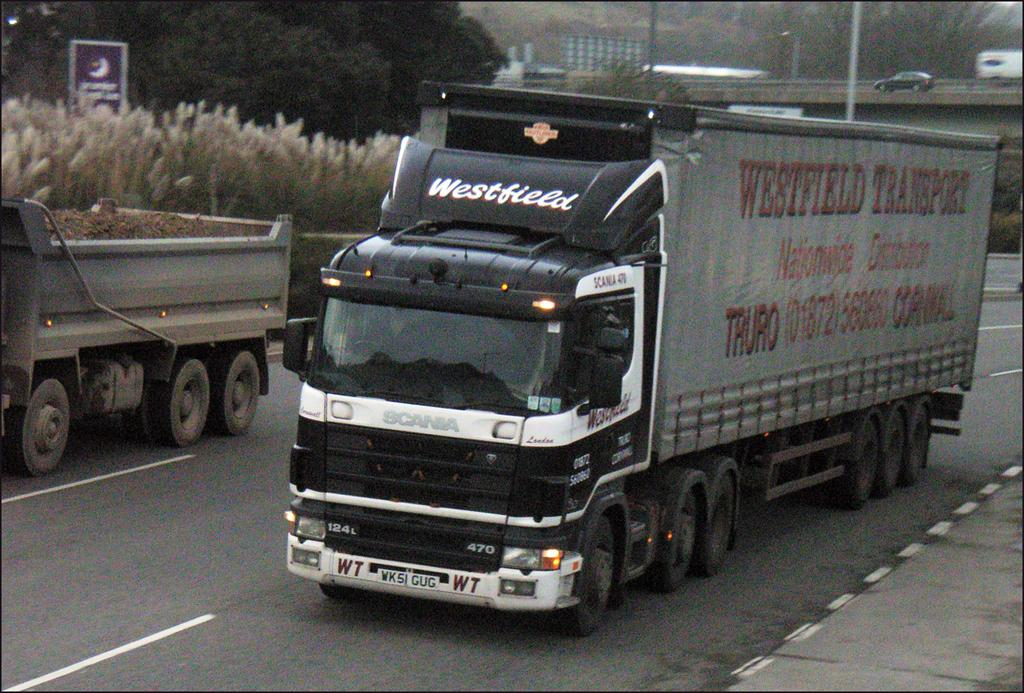What can be seen in the foreground of the picture? There are two trucks on a road and a footpath in the foreground of the picture. What is located in the center of the picture? In the center of the picture, there are plants, trees, a bridge, poles, and vehicles. Can you describe the types of plants and trees in the center of the picture? The specific types of plants and trees are not mentioned, but they are present in the center of the picture. What is the purpose of the poles in the center of the picture? The purpose of the poles is not mentioned, but they are present in the center of the picture. How does the elbow of the person in the picture smash the vehicles? There is no person present in the picture, and therefore no elbow or smashing of vehicles can be observed. What type of food is the person in the picture biting? There is no person present in the picture, and therefore no food or biting can be observed. 